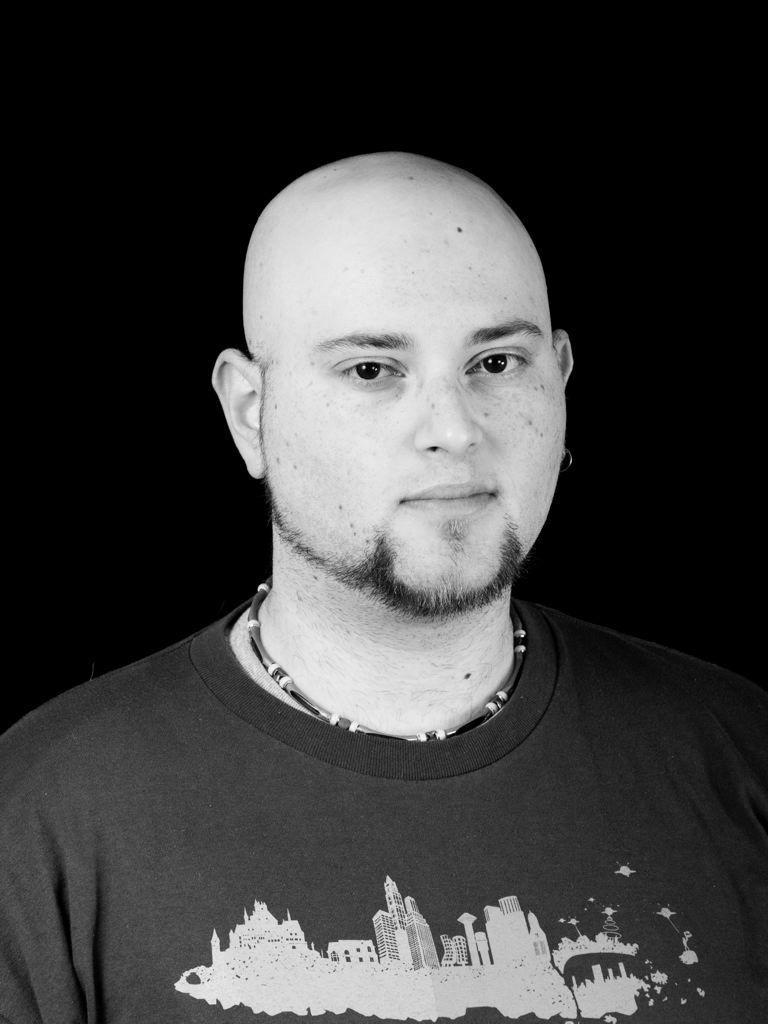Can you describe this image briefly? This is a black and white image. In the picture there is a man. The background is dark. 